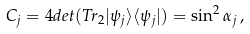Convert formula to latex. <formula><loc_0><loc_0><loc_500><loc_500>C _ { j } = 4 d e t ( T r _ { 2 } | \psi _ { j } \rangle \langle \psi _ { j } | ) = \sin ^ { 2 } \alpha _ { j } \, ,</formula> 